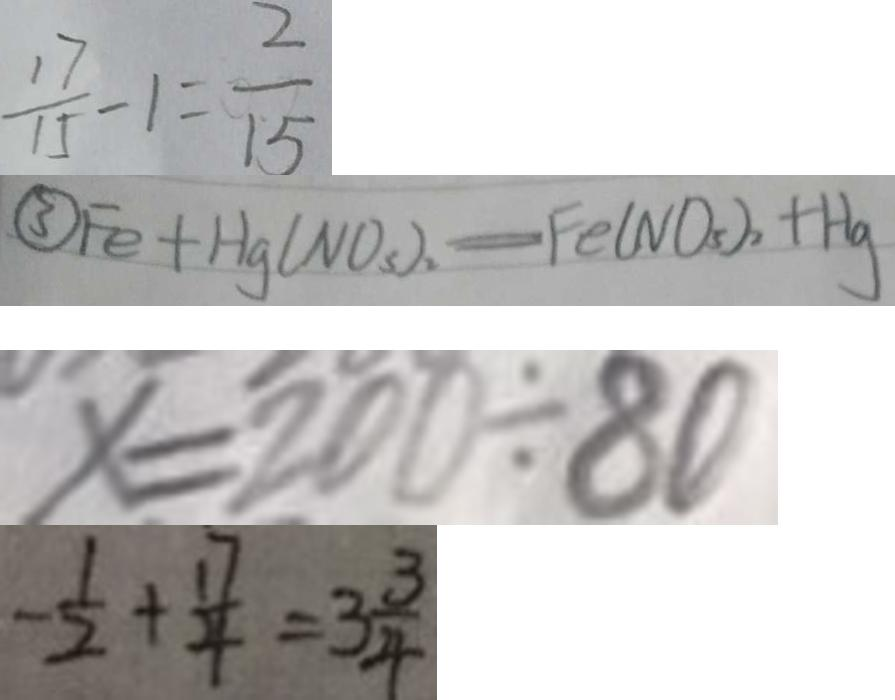Convert formula to latex. <formula><loc_0><loc_0><loc_500><loc_500>\frac { 1 7 } { 1 5 } - 1 = \frac { 2 } { 1 5 } 
 \textcircled { 3 } F e + H g ( N O _ { 5 } ) _ { 2 } = F e ( N O _ { 5 } ) _ { 2 } + H g 
 x = 2 0 0 \div 8 0 
 - \frac { 1 } { 2 } + \frac { 1 7 } { 4 } = 3 \frac { 3 } { 4 }</formula> 